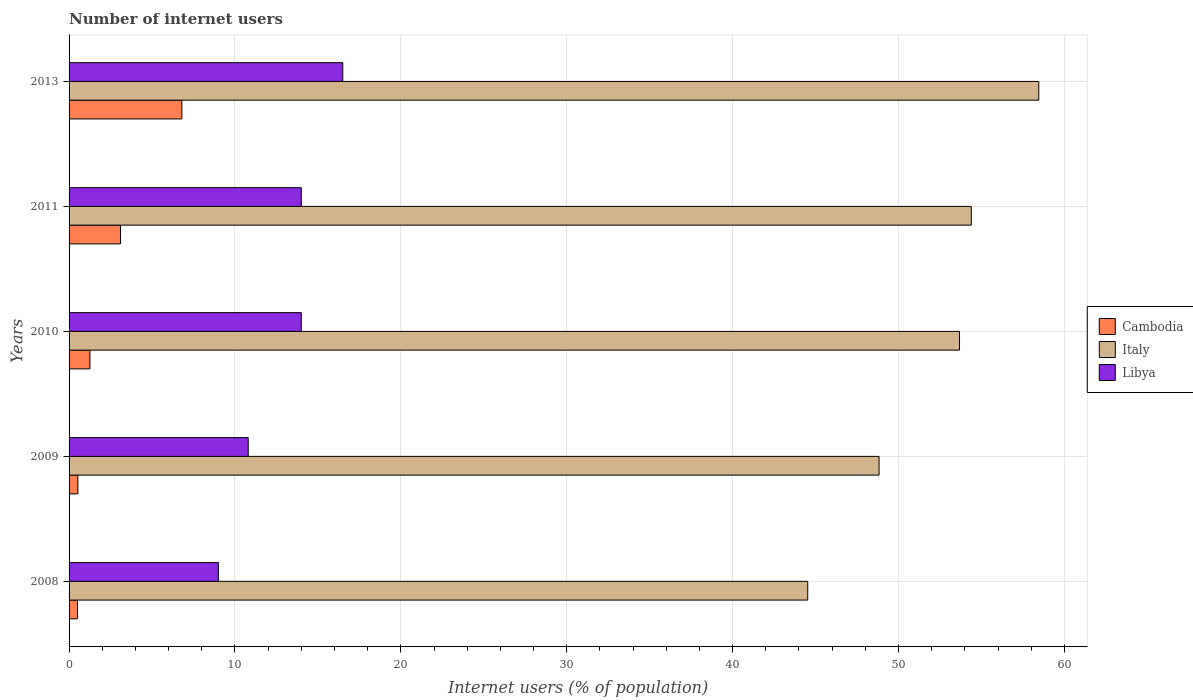How many different coloured bars are there?
Offer a very short reply. 3. How many groups of bars are there?
Give a very brief answer. 5. Are the number of bars per tick equal to the number of legend labels?
Keep it short and to the point. Yes. How many bars are there on the 5th tick from the top?
Provide a short and direct response. 3. How many bars are there on the 2nd tick from the bottom?
Make the answer very short. 3. What is the label of the 2nd group of bars from the top?
Provide a succinct answer. 2011. In how many cases, is the number of bars for a given year not equal to the number of legend labels?
Your answer should be very brief. 0. What is the number of internet users in Libya in 2010?
Your response must be concise. 14. Across all years, what is the maximum number of internet users in Italy?
Give a very brief answer. 58.46. Across all years, what is the minimum number of internet users in Italy?
Your answer should be compact. 44.53. In which year was the number of internet users in Cambodia maximum?
Ensure brevity in your answer.  2013. In which year was the number of internet users in Libya minimum?
Offer a very short reply. 2008. What is the total number of internet users in Italy in the graph?
Give a very brief answer. 259.89. What is the difference between the number of internet users in Cambodia in 2008 and that in 2011?
Offer a terse response. -2.59. What is the difference between the number of internet users in Libya in 2010 and the number of internet users in Cambodia in 2009?
Provide a succinct answer. 13.47. What is the average number of internet users in Cambodia per year?
Make the answer very short. 2.44. In the year 2013, what is the difference between the number of internet users in Libya and number of internet users in Italy?
Your answer should be very brief. -41.96. What is the ratio of the number of internet users in Libya in 2008 to that in 2013?
Your response must be concise. 0.55. Is the difference between the number of internet users in Libya in 2008 and 2011 greater than the difference between the number of internet users in Italy in 2008 and 2011?
Provide a succinct answer. Yes. What is the difference between the highest and the lowest number of internet users in Italy?
Provide a short and direct response. 13.93. In how many years, is the number of internet users in Cambodia greater than the average number of internet users in Cambodia taken over all years?
Provide a short and direct response. 2. What does the 1st bar from the bottom in 2010 represents?
Keep it short and to the point. Cambodia. Is it the case that in every year, the sum of the number of internet users in Cambodia and number of internet users in Libya is greater than the number of internet users in Italy?
Make the answer very short. No. How many bars are there?
Ensure brevity in your answer.  15. Are all the bars in the graph horizontal?
Give a very brief answer. Yes. Are the values on the major ticks of X-axis written in scientific E-notation?
Your response must be concise. No. Does the graph contain grids?
Your answer should be very brief. Yes. What is the title of the graph?
Make the answer very short. Number of internet users. What is the label or title of the X-axis?
Give a very brief answer. Internet users (% of population). What is the label or title of the Y-axis?
Ensure brevity in your answer.  Years. What is the Internet users (% of population) of Cambodia in 2008?
Offer a very short reply. 0.51. What is the Internet users (% of population) of Italy in 2008?
Make the answer very short. 44.53. What is the Internet users (% of population) of Libya in 2008?
Ensure brevity in your answer.  9. What is the Internet users (% of population) of Cambodia in 2009?
Ensure brevity in your answer.  0.53. What is the Internet users (% of population) of Italy in 2009?
Provide a short and direct response. 48.83. What is the Internet users (% of population) in Cambodia in 2010?
Your answer should be compact. 1.26. What is the Internet users (% of population) of Italy in 2010?
Offer a very short reply. 53.68. What is the Internet users (% of population) in Cambodia in 2011?
Offer a terse response. 3.1. What is the Internet users (% of population) of Italy in 2011?
Your response must be concise. 54.39. What is the Internet users (% of population) of Libya in 2011?
Give a very brief answer. 14. What is the Internet users (% of population) in Cambodia in 2013?
Offer a terse response. 6.8. What is the Internet users (% of population) of Italy in 2013?
Your answer should be compact. 58.46. What is the Internet users (% of population) in Libya in 2013?
Keep it short and to the point. 16.5. Across all years, what is the maximum Internet users (% of population) in Cambodia?
Offer a terse response. 6.8. Across all years, what is the maximum Internet users (% of population) of Italy?
Provide a short and direct response. 58.46. Across all years, what is the maximum Internet users (% of population) of Libya?
Provide a short and direct response. 16.5. Across all years, what is the minimum Internet users (% of population) in Cambodia?
Make the answer very short. 0.51. Across all years, what is the minimum Internet users (% of population) of Italy?
Make the answer very short. 44.53. Across all years, what is the minimum Internet users (% of population) in Libya?
Keep it short and to the point. 9. What is the total Internet users (% of population) of Italy in the graph?
Provide a short and direct response. 259.89. What is the total Internet users (% of population) in Libya in the graph?
Ensure brevity in your answer.  64.3. What is the difference between the Internet users (% of population) in Cambodia in 2008 and that in 2009?
Offer a very short reply. -0.02. What is the difference between the Internet users (% of population) in Italy in 2008 and that in 2009?
Offer a very short reply. -4.3. What is the difference between the Internet users (% of population) in Cambodia in 2008 and that in 2010?
Your answer should be very brief. -0.75. What is the difference between the Internet users (% of population) of Italy in 2008 and that in 2010?
Keep it short and to the point. -9.15. What is the difference between the Internet users (% of population) in Cambodia in 2008 and that in 2011?
Your response must be concise. -2.59. What is the difference between the Internet users (% of population) of Italy in 2008 and that in 2011?
Keep it short and to the point. -9.86. What is the difference between the Internet users (% of population) of Cambodia in 2008 and that in 2013?
Offer a terse response. -6.29. What is the difference between the Internet users (% of population) in Italy in 2008 and that in 2013?
Provide a succinct answer. -13.93. What is the difference between the Internet users (% of population) of Libya in 2008 and that in 2013?
Your answer should be very brief. -7.5. What is the difference between the Internet users (% of population) in Cambodia in 2009 and that in 2010?
Your response must be concise. -0.73. What is the difference between the Internet users (% of population) of Italy in 2009 and that in 2010?
Offer a very short reply. -4.85. What is the difference between the Internet users (% of population) in Libya in 2009 and that in 2010?
Provide a short and direct response. -3.2. What is the difference between the Internet users (% of population) of Cambodia in 2009 and that in 2011?
Ensure brevity in your answer.  -2.57. What is the difference between the Internet users (% of population) in Italy in 2009 and that in 2011?
Your answer should be compact. -5.56. What is the difference between the Internet users (% of population) in Libya in 2009 and that in 2011?
Make the answer very short. -3.2. What is the difference between the Internet users (% of population) in Cambodia in 2009 and that in 2013?
Your answer should be compact. -6.27. What is the difference between the Internet users (% of population) in Italy in 2009 and that in 2013?
Give a very brief answer. -9.63. What is the difference between the Internet users (% of population) in Cambodia in 2010 and that in 2011?
Provide a short and direct response. -1.84. What is the difference between the Internet users (% of population) of Italy in 2010 and that in 2011?
Make the answer very short. -0.71. What is the difference between the Internet users (% of population) of Libya in 2010 and that in 2011?
Offer a very short reply. 0. What is the difference between the Internet users (% of population) of Cambodia in 2010 and that in 2013?
Your answer should be compact. -5.54. What is the difference between the Internet users (% of population) in Italy in 2010 and that in 2013?
Provide a short and direct response. -4.78. What is the difference between the Internet users (% of population) in Italy in 2011 and that in 2013?
Give a very brief answer. -4.07. What is the difference between the Internet users (% of population) of Libya in 2011 and that in 2013?
Provide a succinct answer. -2.5. What is the difference between the Internet users (% of population) in Cambodia in 2008 and the Internet users (% of population) in Italy in 2009?
Your answer should be compact. -48.32. What is the difference between the Internet users (% of population) of Cambodia in 2008 and the Internet users (% of population) of Libya in 2009?
Ensure brevity in your answer.  -10.29. What is the difference between the Internet users (% of population) of Italy in 2008 and the Internet users (% of population) of Libya in 2009?
Provide a succinct answer. 33.73. What is the difference between the Internet users (% of population) in Cambodia in 2008 and the Internet users (% of population) in Italy in 2010?
Keep it short and to the point. -53.17. What is the difference between the Internet users (% of population) in Cambodia in 2008 and the Internet users (% of population) in Libya in 2010?
Give a very brief answer. -13.49. What is the difference between the Internet users (% of population) of Italy in 2008 and the Internet users (% of population) of Libya in 2010?
Give a very brief answer. 30.53. What is the difference between the Internet users (% of population) in Cambodia in 2008 and the Internet users (% of population) in Italy in 2011?
Ensure brevity in your answer.  -53.88. What is the difference between the Internet users (% of population) in Cambodia in 2008 and the Internet users (% of population) in Libya in 2011?
Provide a short and direct response. -13.49. What is the difference between the Internet users (% of population) of Italy in 2008 and the Internet users (% of population) of Libya in 2011?
Keep it short and to the point. 30.53. What is the difference between the Internet users (% of population) of Cambodia in 2008 and the Internet users (% of population) of Italy in 2013?
Give a very brief answer. -57.95. What is the difference between the Internet users (% of population) in Cambodia in 2008 and the Internet users (% of population) in Libya in 2013?
Your response must be concise. -15.99. What is the difference between the Internet users (% of population) of Italy in 2008 and the Internet users (% of population) of Libya in 2013?
Offer a very short reply. 28.03. What is the difference between the Internet users (% of population) in Cambodia in 2009 and the Internet users (% of population) in Italy in 2010?
Your response must be concise. -53.15. What is the difference between the Internet users (% of population) of Cambodia in 2009 and the Internet users (% of population) of Libya in 2010?
Your response must be concise. -13.47. What is the difference between the Internet users (% of population) in Italy in 2009 and the Internet users (% of population) in Libya in 2010?
Make the answer very short. 34.83. What is the difference between the Internet users (% of population) of Cambodia in 2009 and the Internet users (% of population) of Italy in 2011?
Your response must be concise. -53.86. What is the difference between the Internet users (% of population) in Cambodia in 2009 and the Internet users (% of population) in Libya in 2011?
Keep it short and to the point. -13.47. What is the difference between the Internet users (% of population) of Italy in 2009 and the Internet users (% of population) of Libya in 2011?
Make the answer very short. 34.83. What is the difference between the Internet users (% of population) in Cambodia in 2009 and the Internet users (% of population) in Italy in 2013?
Your response must be concise. -57.93. What is the difference between the Internet users (% of population) in Cambodia in 2009 and the Internet users (% of population) in Libya in 2013?
Your answer should be compact. -15.97. What is the difference between the Internet users (% of population) in Italy in 2009 and the Internet users (% of population) in Libya in 2013?
Your answer should be compact. 32.33. What is the difference between the Internet users (% of population) in Cambodia in 2010 and the Internet users (% of population) in Italy in 2011?
Keep it short and to the point. -53.13. What is the difference between the Internet users (% of population) in Cambodia in 2010 and the Internet users (% of population) in Libya in 2011?
Make the answer very short. -12.74. What is the difference between the Internet users (% of population) of Italy in 2010 and the Internet users (% of population) of Libya in 2011?
Ensure brevity in your answer.  39.68. What is the difference between the Internet users (% of population) of Cambodia in 2010 and the Internet users (% of population) of Italy in 2013?
Keep it short and to the point. -57.2. What is the difference between the Internet users (% of population) of Cambodia in 2010 and the Internet users (% of population) of Libya in 2013?
Your answer should be compact. -15.24. What is the difference between the Internet users (% of population) in Italy in 2010 and the Internet users (% of population) in Libya in 2013?
Provide a succinct answer. 37.18. What is the difference between the Internet users (% of population) in Cambodia in 2011 and the Internet users (% of population) in Italy in 2013?
Give a very brief answer. -55.36. What is the difference between the Internet users (% of population) of Italy in 2011 and the Internet users (% of population) of Libya in 2013?
Keep it short and to the point. 37.89. What is the average Internet users (% of population) in Cambodia per year?
Your answer should be compact. 2.44. What is the average Internet users (% of population) in Italy per year?
Offer a very short reply. 51.98. What is the average Internet users (% of population) of Libya per year?
Make the answer very short. 12.86. In the year 2008, what is the difference between the Internet users (% of population) of Cambodia and Internet users (% of population) of Italy?
Ensure brevity in your answer.  -44.02. In the year 2008, what is the difference between the Internet users (% of population) in Cambodia and Internet users (% of population) in Libya?
Make the answer very short. -8.49. In the year 2008, what is the difference between the Internet users (% of population) of Italy and Internet users (% of population) of Libya?
Ensure brevity in your answer.  35.53. In the year 2009, what is the difference between the Internet users (% of population) of Cambodia and Internet users (% of population) of Italy?
Offer a terse response. -48.3. In the year 2009, what is the difference between the Internet users (% of population) in Cambodia and Internet users (% of population) in Libya?
Make the answer very short. -10.27. In the year 2009, what is the difference between the Internet users (% of population) of Italy and Internet users (% of population) of Libya?
Your answer should be compact. 38.03. In the year 2010, what is the difference between the Internet users (% of population) in Cambodia and Internet users (% of population) in Italy?
Your answer should be compact. -52.42. In the year 2010, what is the difference between the Internet users (% of population) in Cambodia and Internet users (% of population) in Libya?
Your answer should be compact. -12.74. In the year 2010, what is the difference between the Internet users (% of population) of Italy and Internet users (% of population) of Libya?
Ensure brevity in your answer.  39.68. In the year 2011, what is the difference between the Internet users (% of population) of Cambodia and Internet users (% of population) of Italy?
Provide a succinct answer. -51.29. In the year 2011, what is the difference between the Internet users (% of population) in Cambodia and Internet users (% of population) in Libya?
Ensure brevity in your answer.  -10.9. In the year 2011, what is the difference between the Internet users (% of population) in Italy and Internet users (% of population) in Libya?
Make the answer very short. 40.39. In the year 2013, what is the difference between the Internet users (% of population) of Cambodia and Internet users (% of population) of Italy?
Offer a terse response. -51.66. In the year 2013, what is the difference between the Internet users (% of population) of Italy and Internet users (% of population) of Libya?
Offer a terse response. 41.96. What is the ratio of the Internet users (% of population) in Cambodia in 2008 to that in 2009?
Offer a very short reply. 0.96. What is the ratio of the Internet users (% of population) of Italy in 2008 to that in 2009?
Keep it short and to the point. 0.91. What is the ratio of the Internet users (% of population) in Libya in 2008 to that in 2009?
Your answer should be compact. 0.83. What is the ratio of the Internet users (% of population) in Cambodia in 2008 to that in 2010?
Make the answer very short. 0.4. What is the ratio of the Internet users (% of population) in Italy in 2008 to that in 2010?
Your response must be concise. 0.83. What is the ratio of the Internet users (% of population) in Libya in 2008 to that in 2010?
Make the answer very short. 0.64. What is the ratio of the Internet users (% of population) of Cambodia in 2008 to that in 2011?
Keep it short and to the point. 0.16. What is the ratio of the Internet users (% of population) of Italy in 2008 to that in 2011?
Make the answer very short. 0.82. What is the ratio of the Internet users (% of population) in Libya in 2008 to that in 2011?
Offer a very short reply. 0.64. What is the ratio of the Internet users (% of population) of Cambodia in 2008 to that in 2013?
Provide a short and direct response. 0.07. What is the ratio of the Internet users (% of population) of Italy in 2008 to that in 2013?
Provide a succinct answer. 0.76. What is the ratio of the Internet users (% of population) of Libya in 2008 to that in 2013?
Give a very brief answer. 0.55. What is the ratio of the Internet users (% of population) in Cambodia in 2009 to that in 2010?
Ensure brevity in your answer.  0.42. What is the ratio of the Internet users (% of population) of Italy in 2009 to that in 2010?
Give a very brief answer. 0.91. What is the ratio of the Internet users (% of population) of Libya in 2009 to that in 2010?
Offer a terse response. 0.77. What is the ratio of the Internet users (% of population) of Cambodia in 2009 to that in 2011?
Your answer should be compact. 0.17. What is the ratio of the Internet users (% of population) of Italy in 2009 to that in 2011?
Make the answer very short. 0.9. What is the ratio of the Internet users (% of population) of Libya in 2009 to that in 2011?
Provide a short and direct response. 0.77. What is the ratio of the Internet users (% of population) in Cambodia in 2009 to that in 2013?
Make the answer very short. 0.08. What is the ratio of the Internet users (% of population) in Italy in 2009 to that in 2013?
Keep it short and to the point. 0.84. What is the ratio of the Internet users (% of population) of Libya in 2009 to that in 2013?
Your response must be concise. 0.65. What is the ratio of the Internet users (% of population) in Cambodia in 2010 to that in 2011?
Make the answer very short. 0.41. What is the ratio of the Internet users (% of population) of Italy in 2010 to that in 2011?
Give a very brief answer. 0.99. What is the ratio of the Internet users (% of population) in Libya in 2010 to that in 2011?
Give a very brief answer. 1. What is the ratio of the Internet users (% of population) in Cambodia in 2010 to that in 2013?
Your answer should be very brief. 0.19. What is the ratio of the Internet users (% of population) of Italy in 2010 to that in 2013?
Provide a succinct answer. 0.92. What is the ratio of the Internet users (% of population) in Libya in 2010 to that in 2013?
Your answer should be compact. 0.85. What is the ratio of the Internet users (% of population) in Cambodia in 2011 to that in 2013?
Ensure brevity in your answer.  0.46. What is the ratio of the Internet users (% of population) of Italy in 2011 to that in 2013?
Ensure brevity in your answer.  0.93. What is the ratio of the Internet users (% of population) of Libya in 2011 to that in 2013?
Make the answer very short. 0.85. What is the difference between the highest and the second highest Internet users (% of population) of Cambodia?
Give a very brief answer. 3.7. What is the difference between the highest and the second highest Internet users (% of population) in Italy?
Ensure brevity in your answer.  4.07. What is the difference between the highest and the second highest Internet users (% of population) in Libya?
Your answer should be compact. 2.5. What is the difference between the highest and the lowest Internet users (% of population) of Cambodia?
Your response must be concise. 6.29. What is the difference between the highest and the lowest Internet users (% of population) of Italy?
Offer a terse response. 13.93. 